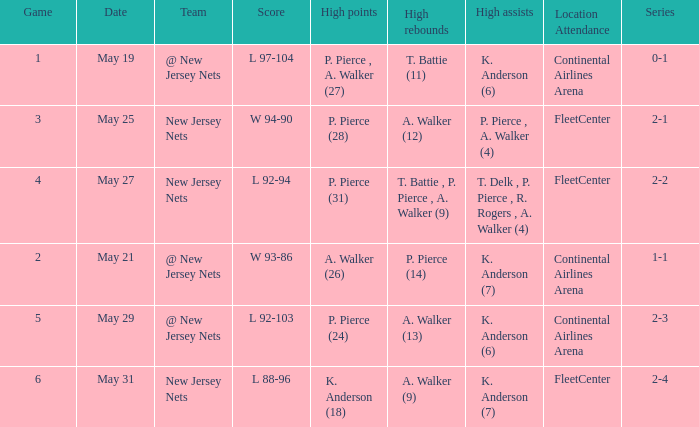What was the highest assists for game 3? P. Pierce , A. Walker (4). 